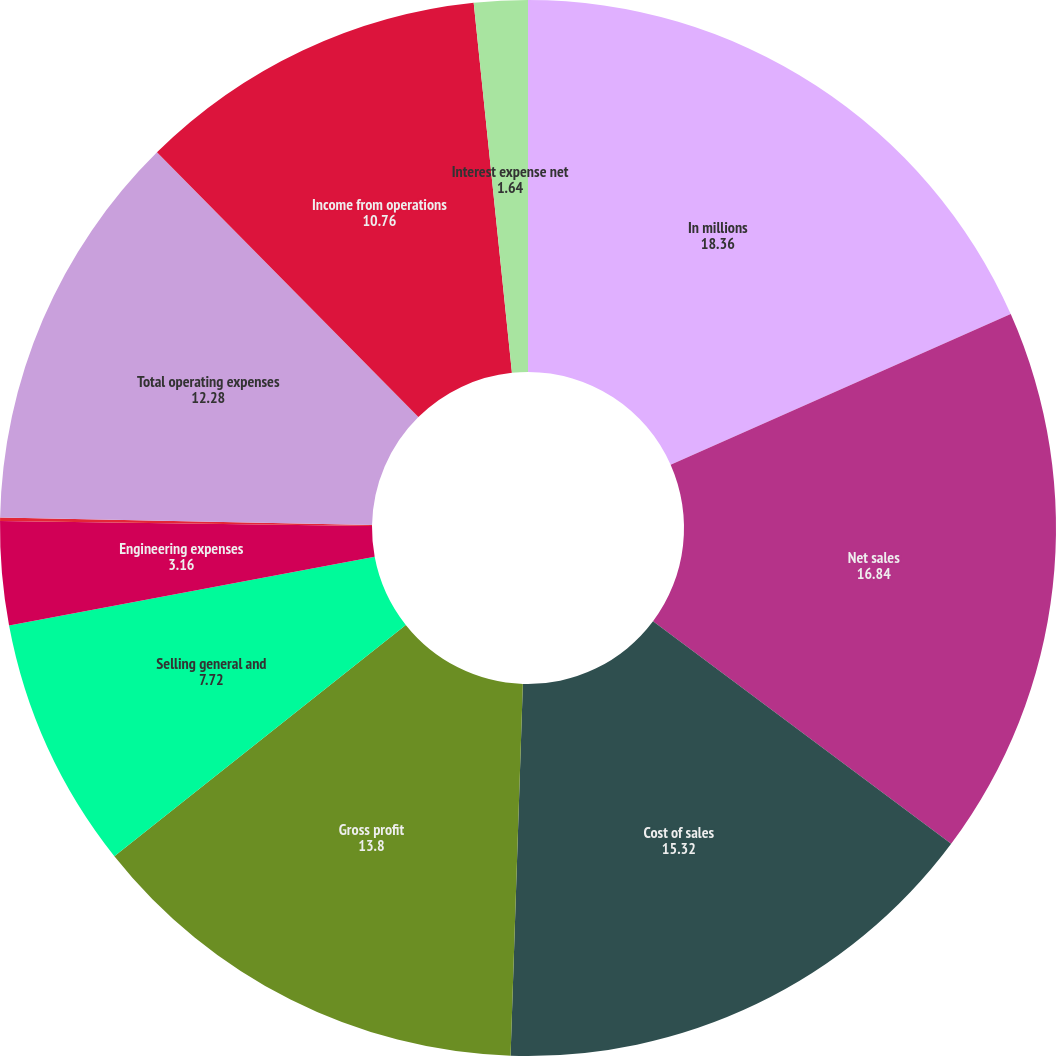Convert chart. <chart><loc_0><loc_0><loc_500><loc_500><pie_chart><fcel>In millions<fcel>Net sales<fcel>Cost of sales<fcel>Gross profit<fcel>Selling general and<fcel>Engineering expenses<fcel>Amortization expense<fcel>Total operating expenses<fcel>Income from operations<fcel>Interest expense net<nl><fcel>18.36%<fcel>16.84%<fcel>15.32%<fcel>13.8%<fcel>7.72%<fcel>3.16%<fcel>0.11%<fcel>12.28%<fcel>10.76%<fcel>1.64%<nl></chart> 